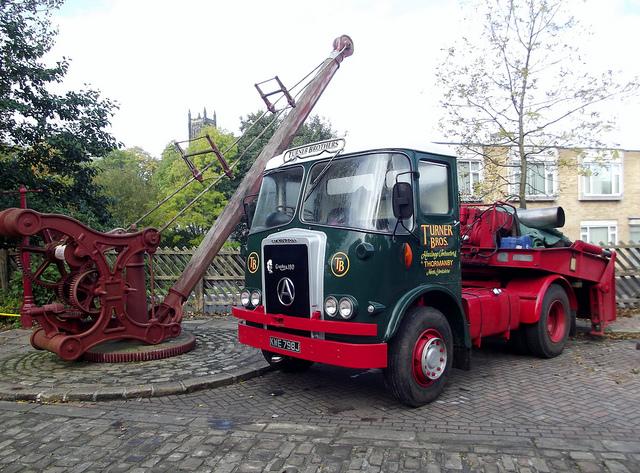What color is the truck?
Be succinct. Green and red. What's the name of the construction company?
Give a very brief answer. Turner bros. Is it night time?
Be succinct. No. What is the road made out of?
Write a very short answer. Bricks. 